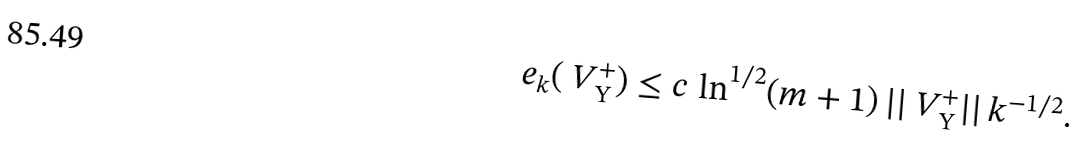<formula> <loc_0><loc_0><loc_500><loc_500>e _ { k } ( \ V _ { \Upsilon } ^ { + } ) \leq c \, \ln ^ { 1 / 2 } ( m + 1 ) \, | | \ V _ { \Upsilon } ^ { + } | | \, k ^ { - 1 / 2 } .</formula> 